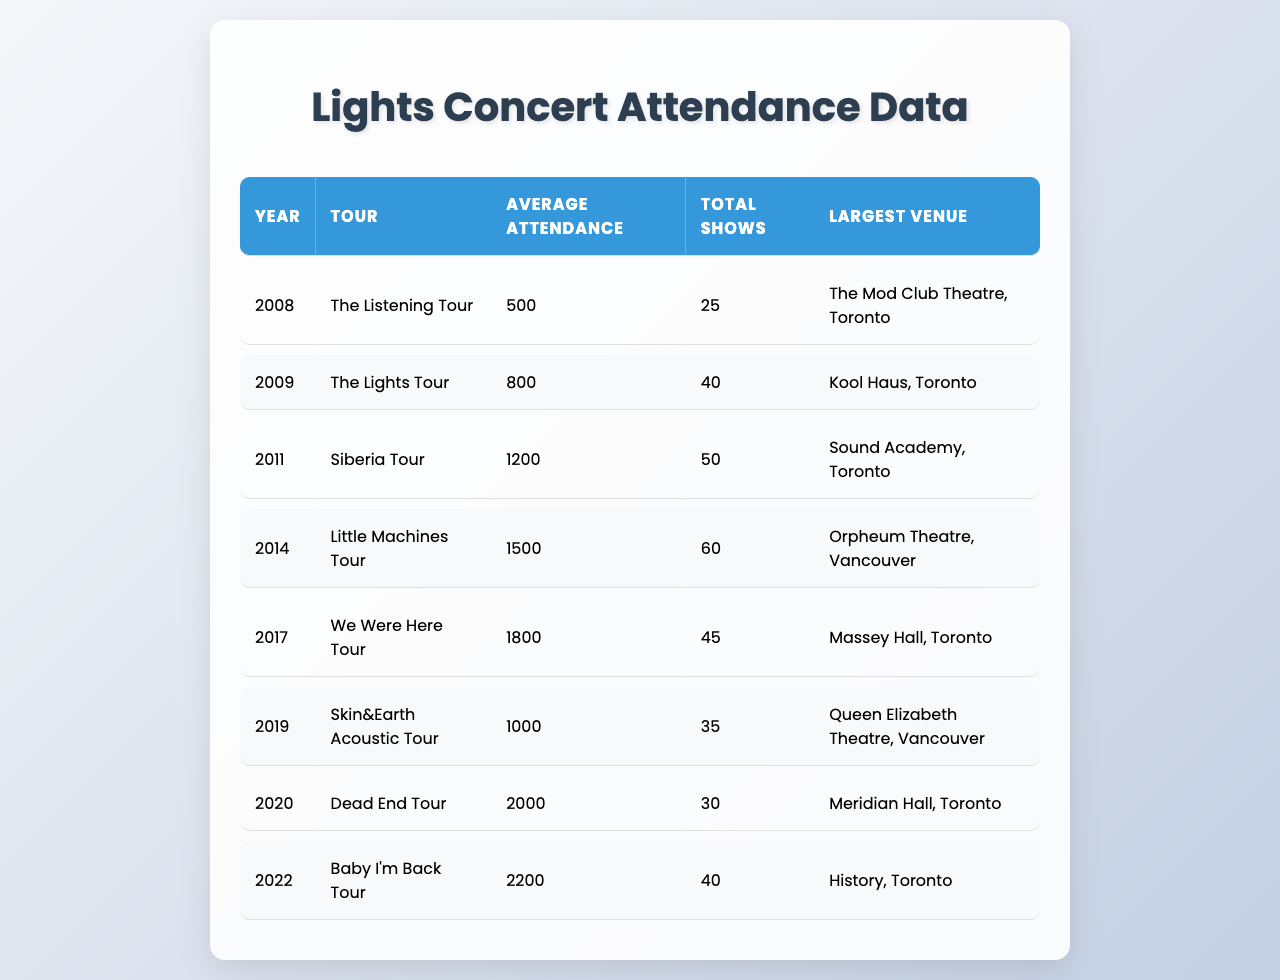What is the average attendance for the Little Machines Tour? The table states that the Little Machines Tour took place in 2014 with an average attendance of 1500.
Answer: 1500 In which year did Lights have the largest average concert attendance? By reviewing the average attendance values, the highest is 2200 for the Baby I'm Back Tour in 2022.
Answer: 2022 How many total shows did Lights perform during the Siberia Tour? The Siberia Tour happened in 2011, and the table indicates there were a total of 50 shows during that year.
Answer: 50 True or False: The average attendance for the Dead End Tour was greater than 1500. The Dead End Tour in 2020 had an average attendance of 2000, which is indeed greater than 1500.
Answer: True What is the difference in average attendance between the We Were Here Tour and the Skin&Earth Acoustic Tour? We Were Here Tour had an average attendance of 1800 and the Skin&Earth Acoustic Tour had 1000. The difference is 1800 - 1000 = 800.
Answer: 800 Which tour had the largest venue, and what was its name? The tour with the largest venue was the Dead End Tour in 2020, held at Meridian Hall, Toronto.
Answer: Dead End Tour, Meridian Hall Calculate the total attendance across all shows for the Baby I'm Back Tour. The average attendance for the Baby I'm Back Tour is 2200, and there were 40 shows. Therefore, total attendance is 2200 * 40 = 88000.
Answer: 88000 What two tours had the highest total number of shows? By analyzing the total shows, the Little Machines Tour (60 shows) and the Siberia Tour (50 shows) had the highest, totaling 110 shows combined.
Answer: 110 shows How many years separate the largest venue for the Dead End Tour and the smallest venue for The Listening Tour? The largest venue was for the Dead End Tour (2020) and the smallest was The Listening Tour (2008). The difference in years is 2020 - 2008 = 12 years.
Answer: 12 years True or False: The Lights Tour had more total shows than the We Were Here Tour. The Lights Tour (2009) had 40 shows and the We Were Here Tour (2017) had 45 shows. Since 40 is less than 45, the statement is false.
Answer: False If Lights' average attendance increased at a steady rate from the Listening Tour to the Baby I'm Back Tour, what would be the average annual increase? The Listening Tour had an average of 500 and the Baby I'm Back Tour had 2200, over 14 years (from 2008 to 2022), gives an increase of (2200 - 500) / 14 = 121.43 per year approximately.
Answer: 121.43 per year 